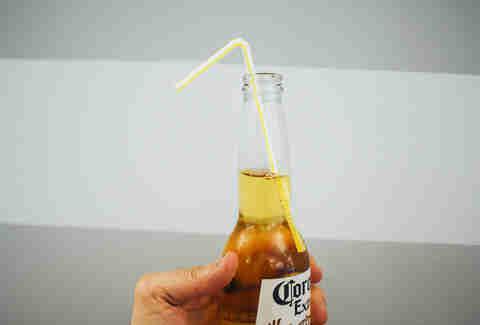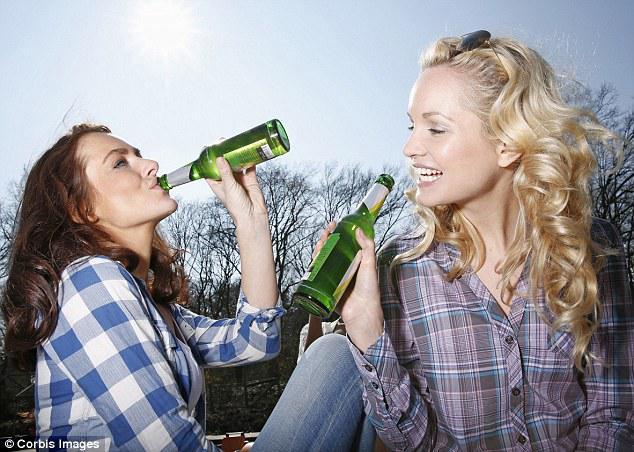The first image is the image on the left, the second image is the image on the right. Considering the images on both sides, is "In the right image, one person is lifting a glass bottle to drink, with their head tilted back." valid? Answer yes or no. Yes. The first image is the image on the left, the second image is the image on the right. Assess this claim about the two images: "In at least one image there are two people holding beer bottles.". Correct or not? Answer yes or no. Yes. 